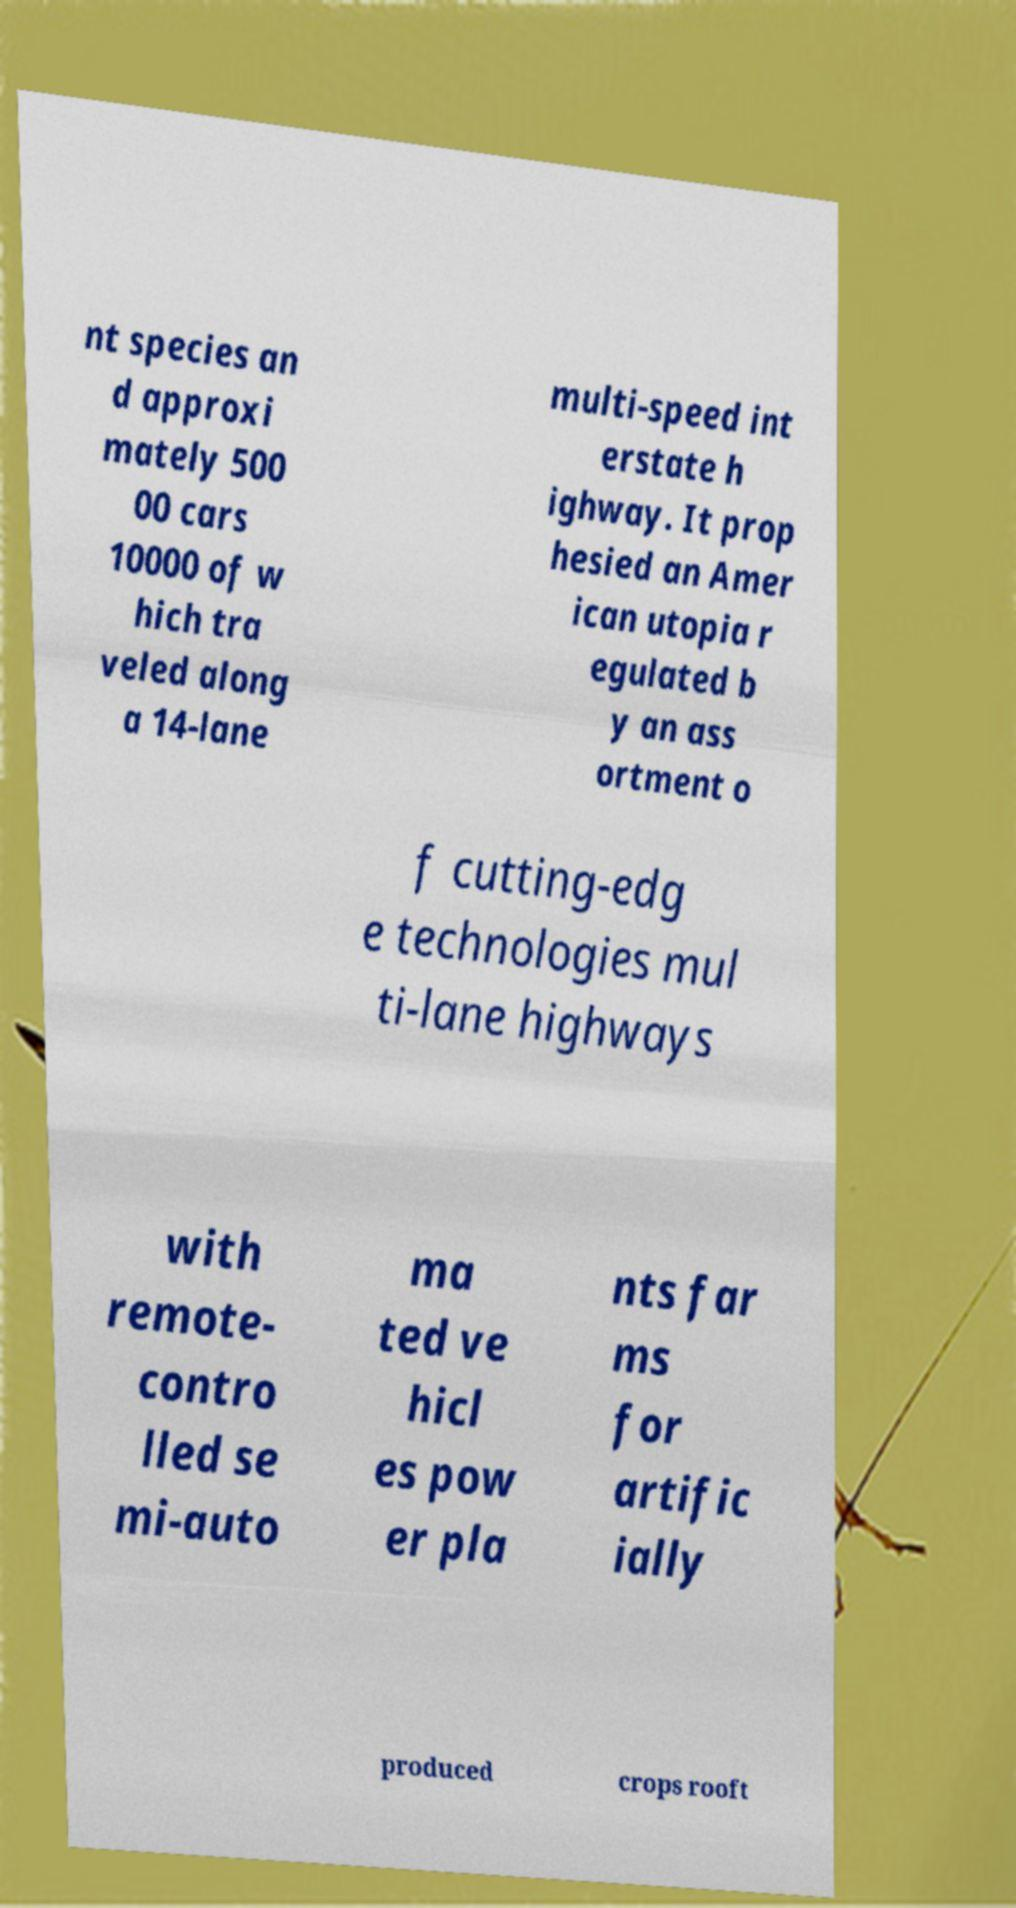I need the written content from this picture converted into text. Can you do that? nt species an d approxi mately 500 00 cars 10000 of w hich tra veled along a 14-lane multi-speed int erstate h ighway. It prop hesied an Amer ican utopia r egulated b y an ass ortment o f cutting-edg e technologies mul ti-lane highways with remote- contro lled se mi-auto ma ted ve hicl es pow er pla nts far ms for artific ially produced crops rooft 